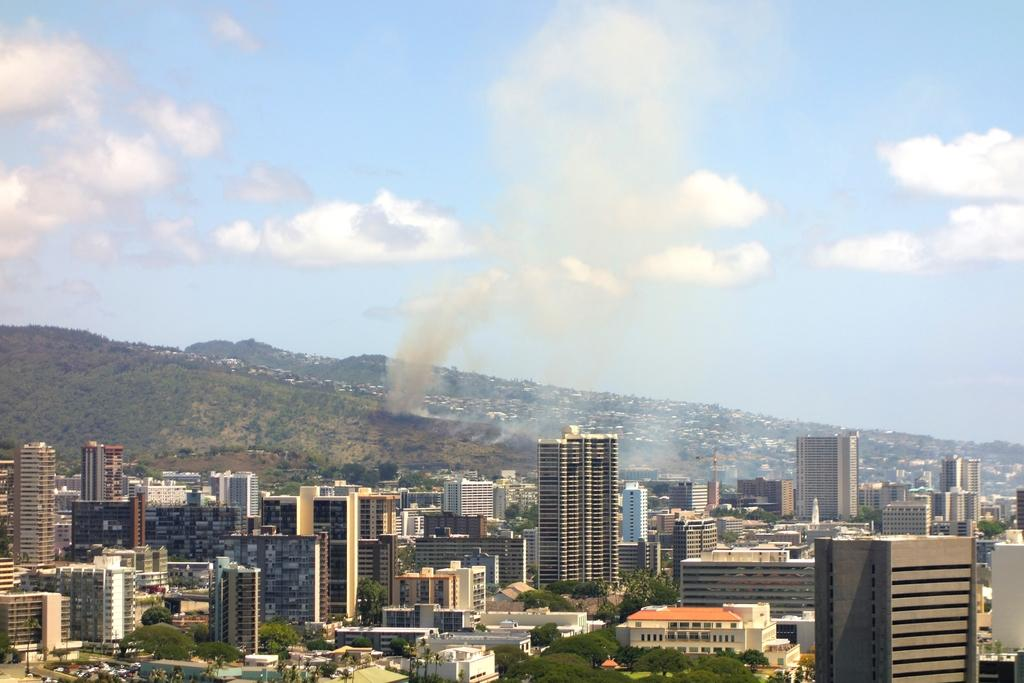What is the weather like in the image? The sky in the image is cloudy. What can be seen coming from the buildings or hills in the image? There is smoke visible in the image. What type of landscape is depicted in the image? There are hills in the image. What structures are present at the bottom of the image? There are many buildings at the bottom of the image. What type of vegetation is present at the bottom of the image? Trees are present at the bottom of the image. What grade did the student receive for their thunder performance in the image? There is no student or thunder performance present in the image. Where is the hall located in the image? There is no hall present in the image. 